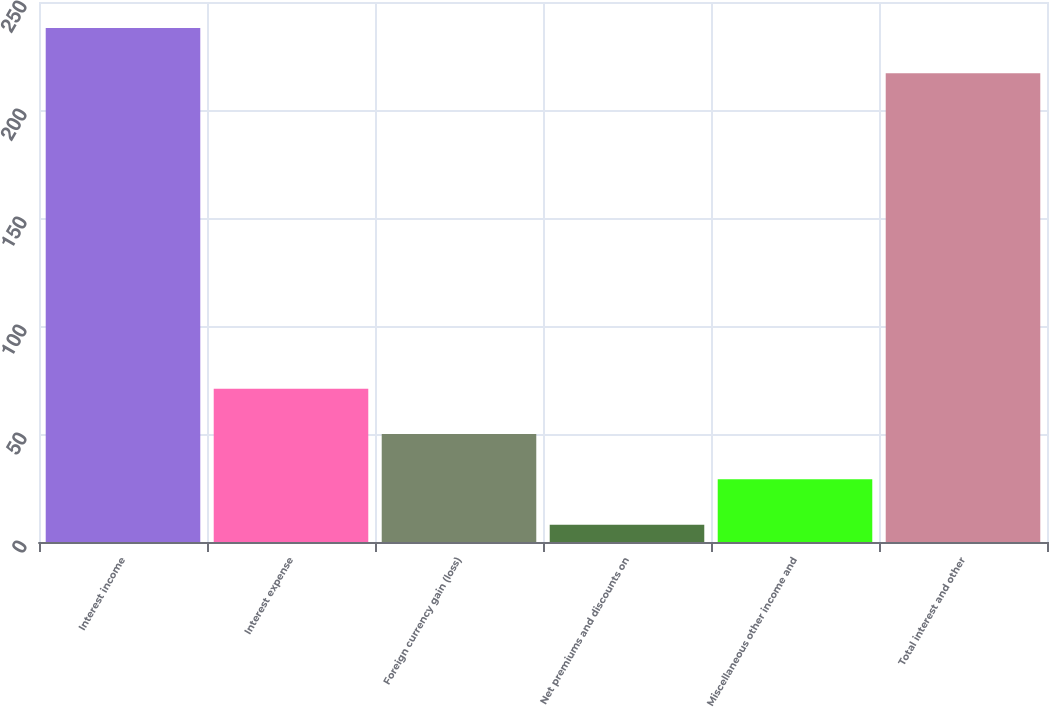Convert chart to OTSL. <chart><loc_0><loc_0><loc_500><loc_500><bar_chart><fcel>Interest income<fcel>Interest expense<fcel>Foreign currency gain (loss)<fcel>Net premiums and discounts on<fcel>Miscellaneous other income and<fcel>Total interest and other<nl><fcel>238<fcel>71<fcel>50<fcel>8<fcel>29<fcel>217<nl></chart> 